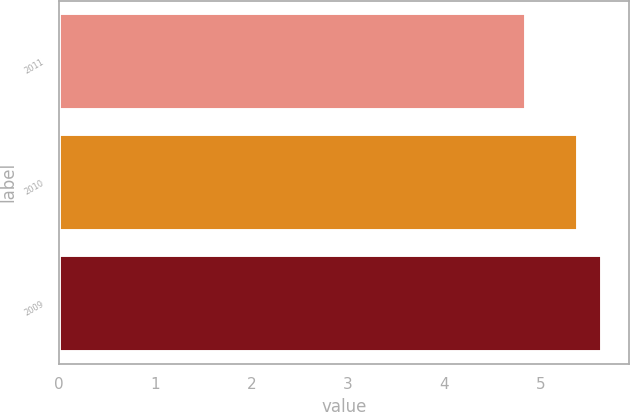Convert chart. <chart><loc_0><loc_0><loc_500><loc_500><bar_chart><fcel>2011<fcel>2010<fcel>2009<nl><fcel>4.85<fcel>5.39<fcel>5.64<nl></chart> 